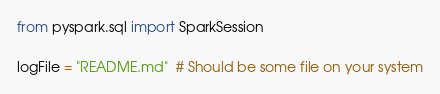Convert code to text. <code><loc_0><loc_0><loc_500><loc_500><_Python_>from pyspark.sql import SparkSession

logFile = "README.md"  # Should be some file on your system</code> 